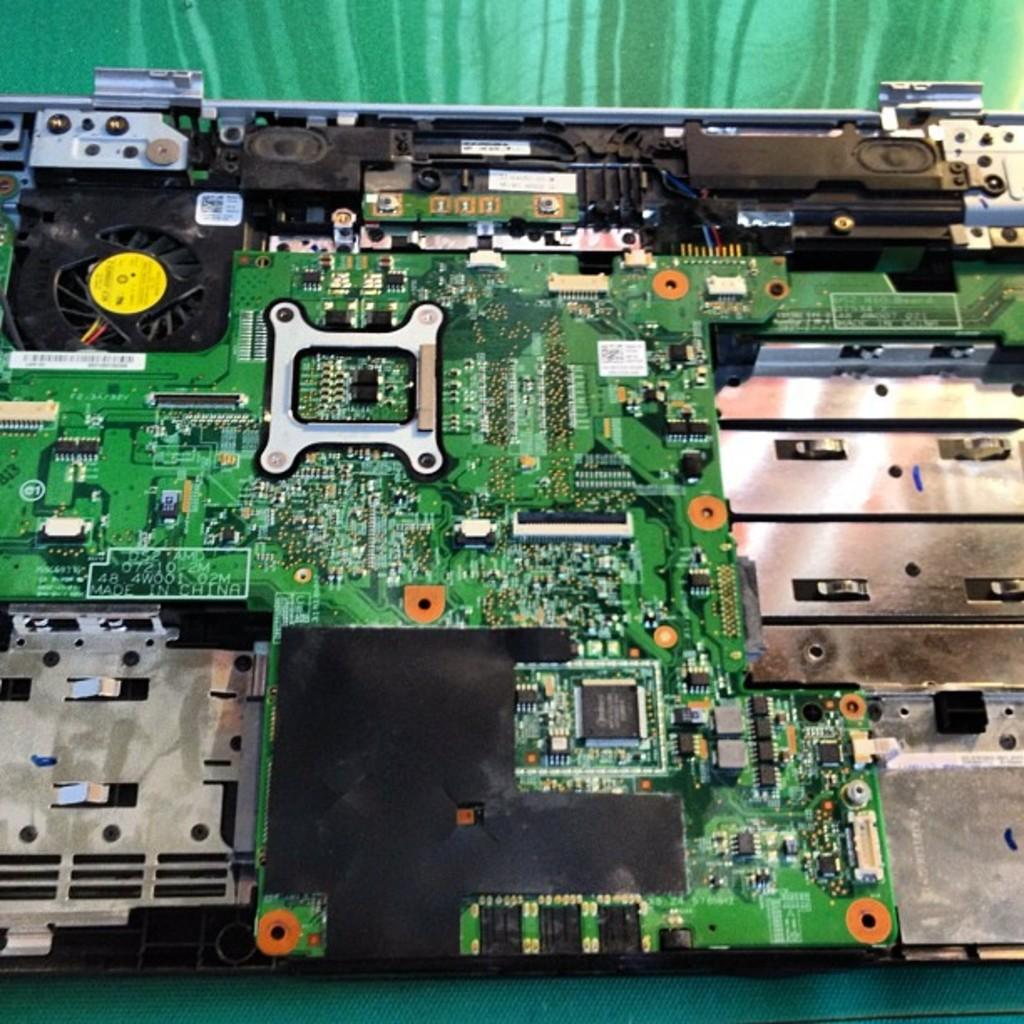What type of object is the main subject in the image? There is an electronic device in the image. What type of patch is visible on the notebook in the image? There is no notebook or patch present in the image; it only features an electronic device. 